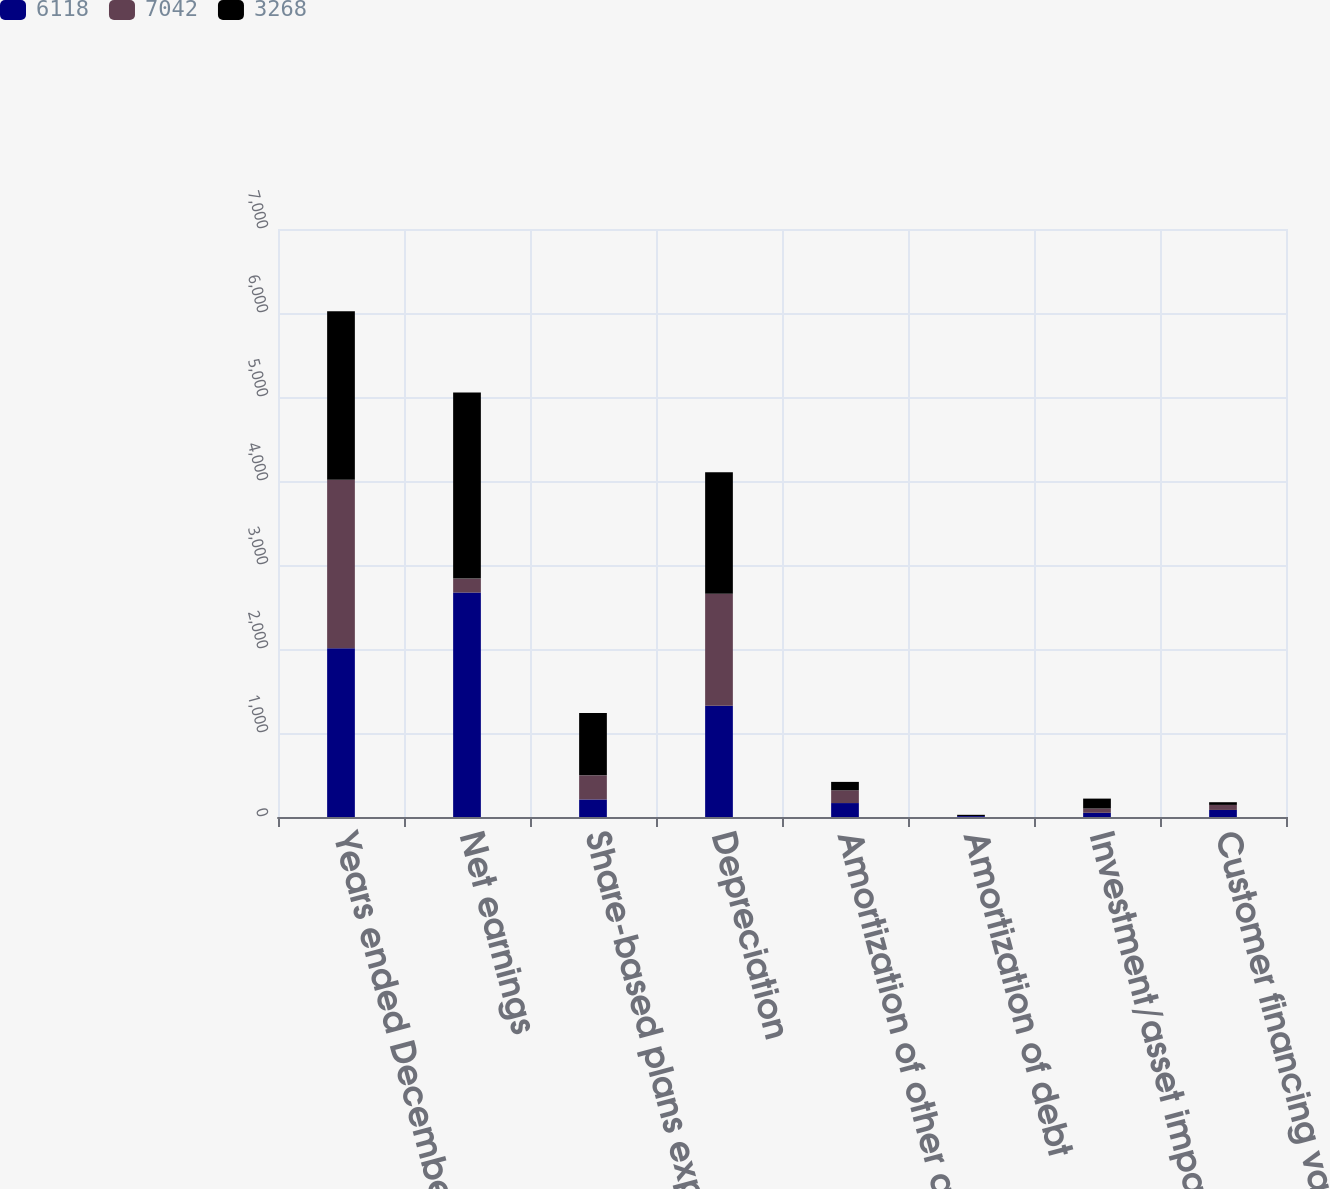<chart> <loc_0><loc_0><loc_500><loc_500><stacked_bar_chart><ecel><fcel>Years ended December 31<fcel>Net earnings<fcel>Share-based plans expense<fcel>Depreciation<fcel>Amortization of other acquired<fcel>Amortization of debt<fcel>Investment/asset impairment<fcel>Customer financing valuation<nl><fcel>6118<fcel>2008<fcel>2672<fcel>209<fcel>1325<fcel>166<fcel>11<fcel>50<fcel>84<nl><fcel>7042<fcel>2007<fcel>166<fcel>287<fcel>1334<fcel>152<fcel>1<fcel>51<fcel>60<nl><fcel>3268<fcel>2006<fcel>2215<fcel>743<fcel>1445<fcel>100<fcel>14<fcel>118<fcel>32<nl></chart> 